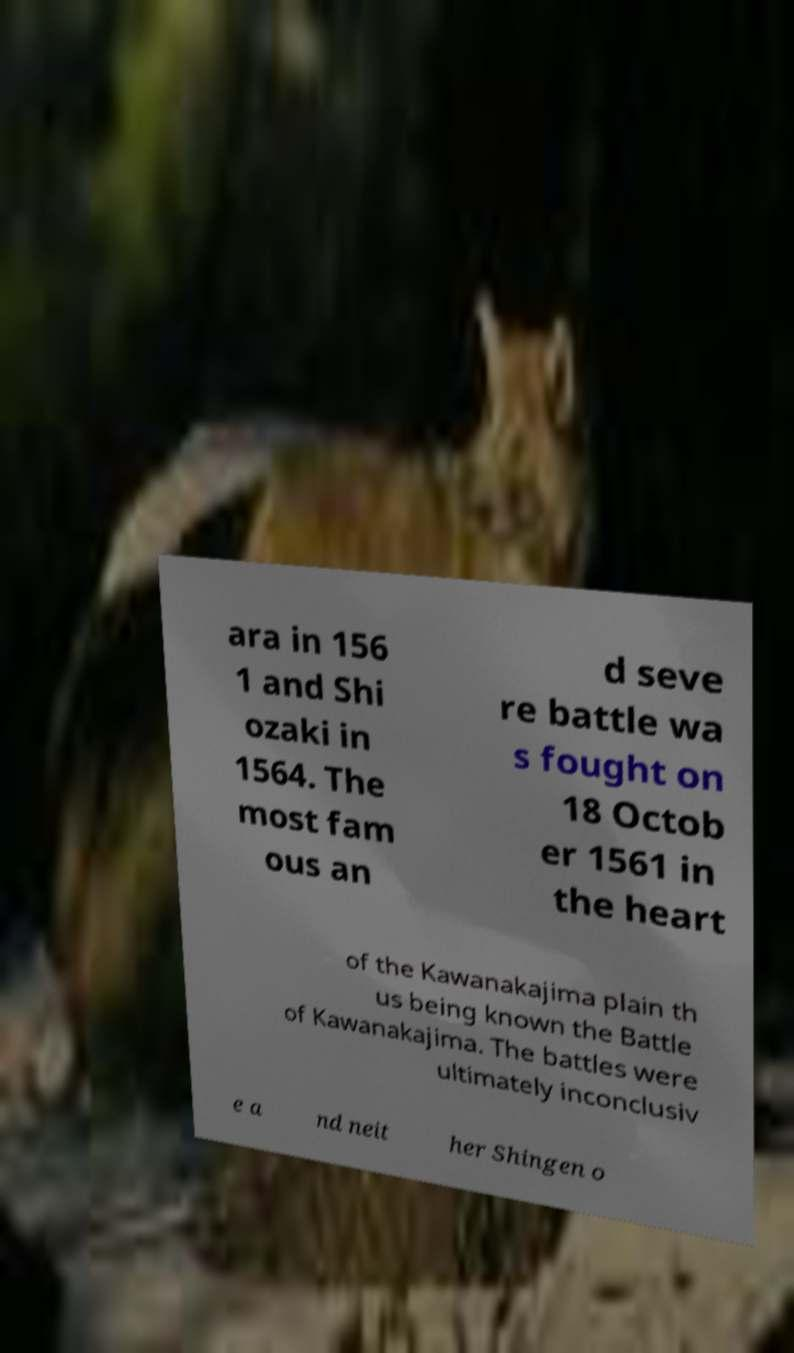Please read and relay the text visible in this image. What does it say? ara in 156 1 and Shi ozaki in 1564. The most fam ous an d seve re battle wa s fought on 18 Octob er 1561 in the heart of the Kawanakajima plain th us being known the Battle of Kawanakajima. The battles were ultimately inconclusiv e a nd neit her Shingen o 